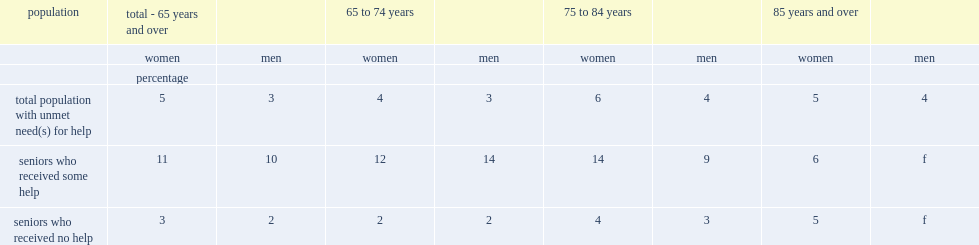What's the percentage of women aged 65 and over living in private households reported at least one unmet need for help with daily activities. 5.0. Which is higher among senior women who had received help and lower among those who had not. Seniors who received some help. What's the percentage of senior men reported having unmet needs for help. 3.0. 